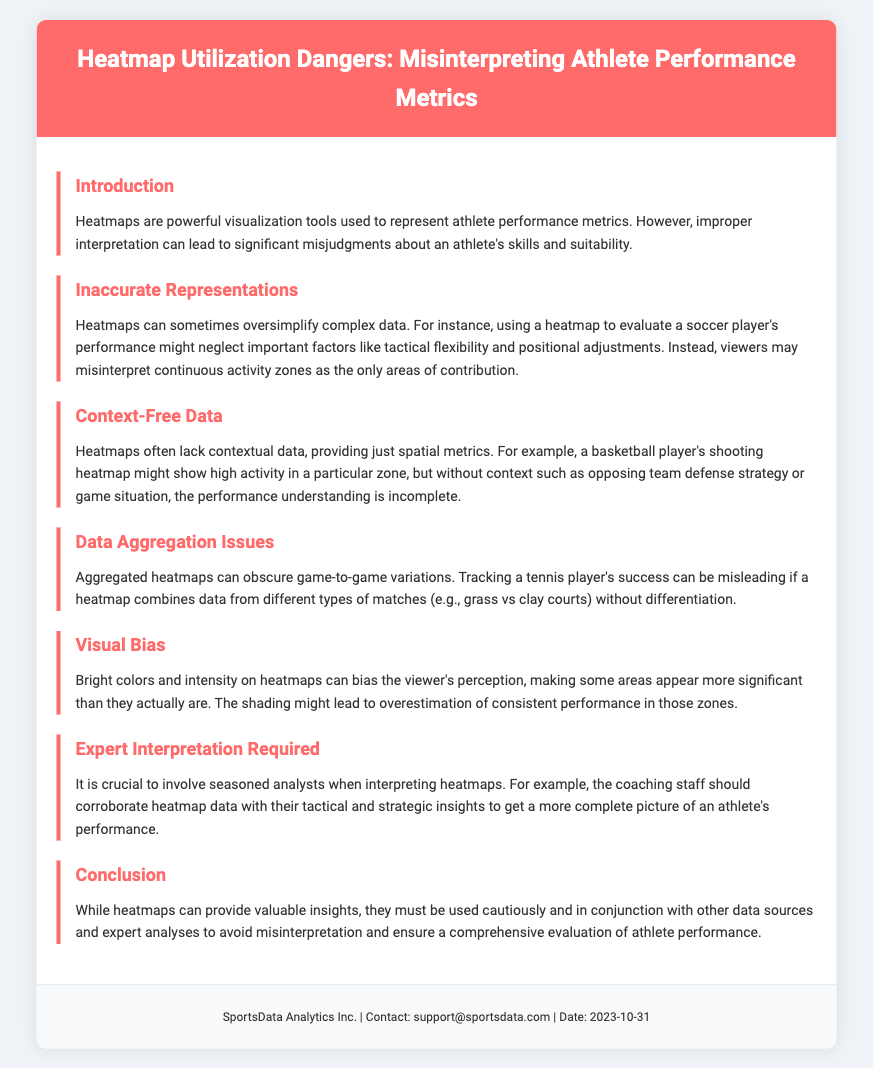What is the title of the document? The title of the document is specified in the header section under the main heading.
Answer: Heatmap Utilization Dangers: Misinterpreting Athlete Performance Metrics What does the introduction warn about? The introduction mentions the risk of improper interpretation of heatmaps and the consequences it can have.
Answer: Misjudgments about an athlete's skills and suitability What important factor can be neglected when evaluating a soccer player's performance with a heatmap? The document specifies that important factors can be overlooked when using heatmaps, particularly for soccer players.
Answer: Tactical flexibility and positional adjustments What type of data do heatmaps often lack? The document highlights the types of information that are missing from heatmaps, particularly spatial data.
Answer: Contextual data What issue arises from aggregated heatmaps according to the document? The section on data aggregation mentions the consequences of combining data from different scenarios without differentiation.
Answer: Obscuring game-to-game variations What visual element can bias the viewer's perception on heatmaps? The document discusses elements that can influence how performance metrics are interpreted visually.
Answer: Bright colors and intensity Who is crucial for interpreting heatmaps effectively? The document provides insight into who should be involved in analyzing the data presented in heatmaps.
Answer: Seasoned analysts What is the final advice given in the conclusion? The conclusion emphasizes the necessary precautions when using heatmaps.
Answer: Use cautiously and in conjunction with other data sources and expert analyses 